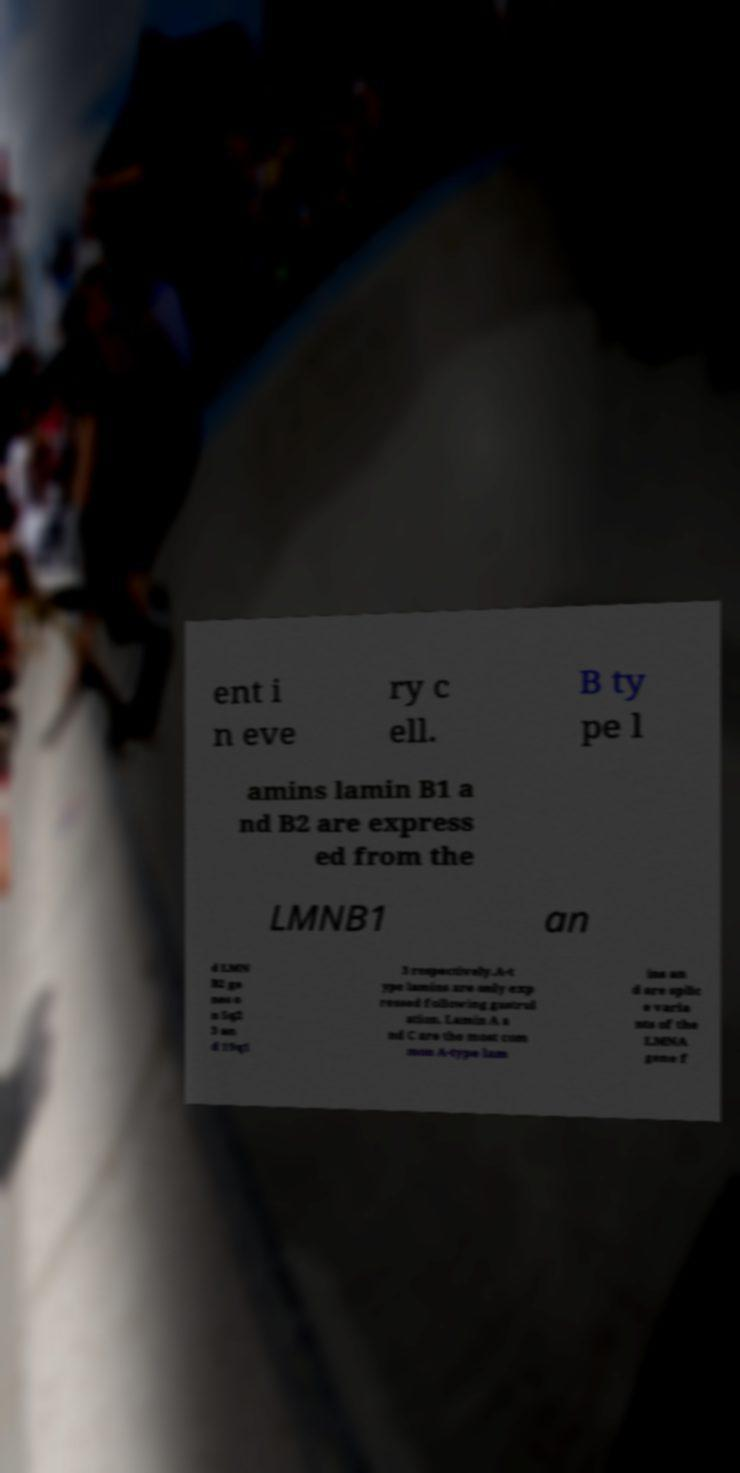Please identify and transcribe the text found in this image. ent i n eve ry c ell. B ty pe l amins lamin B1 a nd B2 are express ed from the LMNB1 an d LMN B2 ge nes o n 5q2 3 an d 19q1 3 respectively.A-t ype lamins are only exp ressed following gastrul ation. Lamin A a nd C are the most com mon A-type lam ins an d are splic e varia nts of the LMNA gene f 